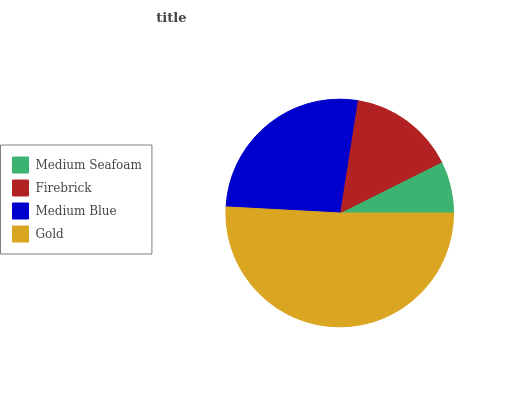Is Medium Seafoam the minimum?
Answer yes or no. Yes. Is Gold the maximum?
Answer yes or no. Yes. Is Firebrick the minimum?
Answer yes or no. No. Is Firebrick the maximum?
Answer yes or no. No. Is Firebrick greater than Medium Seafoam?
Answer yes or no. Yes. Is Medium Seafoam less than Firebrick?
Answer yes or no. Yes. Is Medium Seafoam greater than Firebrick?
Answer yes or no. No. Is Firebrick less than Medium Seafoam?
Answer yes or no. No. Is Medium Blue the high median?
Answer yes or no. Yes. Is Firebrick the low median?
Answer yes or no. Yes. Is Firebrick the high median?
Answer yes or no. No. Is Medium Blue the low median?
Answer yes or no. No. 